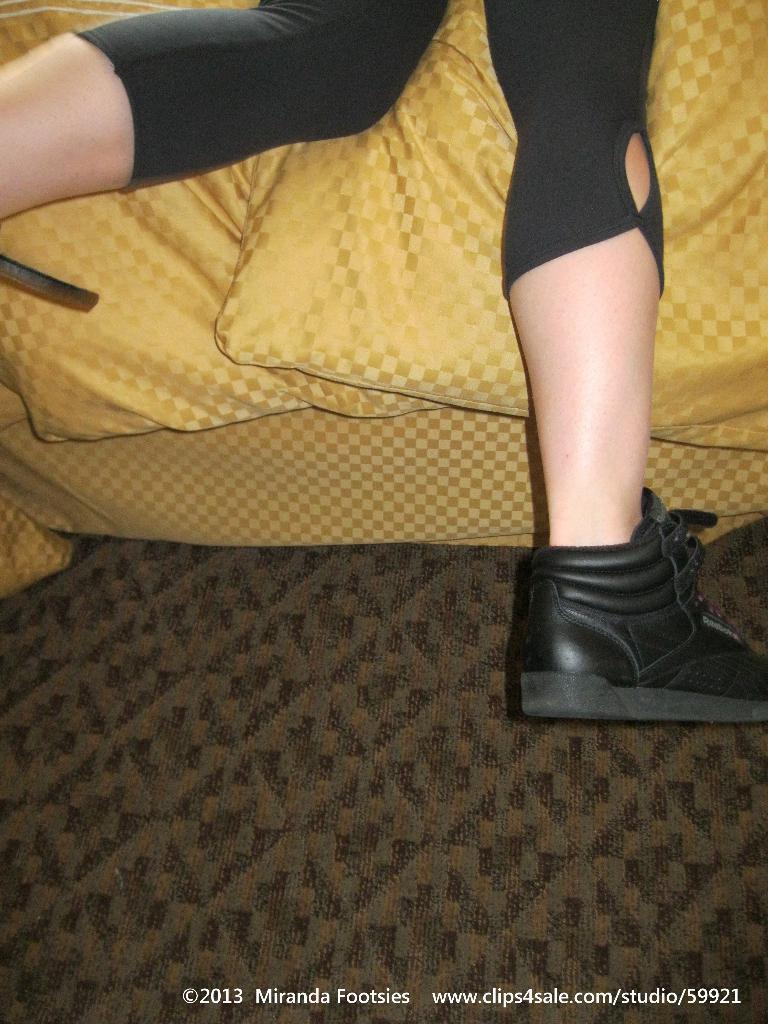How would you summarize this image in a sentence or two? In this image we can see there is a person's leg and the person is wearing shoes. 